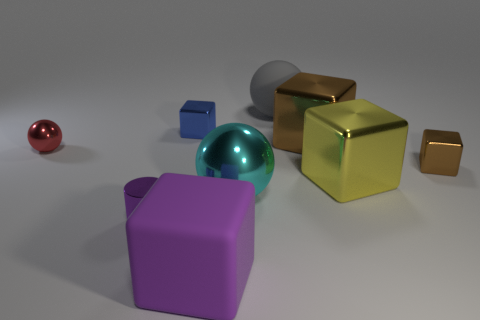Subtract all tiny brown metal cubes. How many cubes are left? 4 Add 1 tiny cubes. How many objects exist? 10 Subtract 1 cylinders. How many cylinders are left? 0 Subtract all cylinders. How many objects are left? 8 Subtract all yellow blocks. How many blocks are left? 4 Subtract 1 blue blocks. How many objects are left? 8 Subtract all brown blocks. Subtract all blue spheres. How many blocks are left? 3 Subtract all cyan blocks. How many brown cylinders are left? 0 Subtract all small brown metal things. Subtract all yellow things. How many objects are left? 7 Add 1 big gray matte things. How many big gray matte things are left? 2 